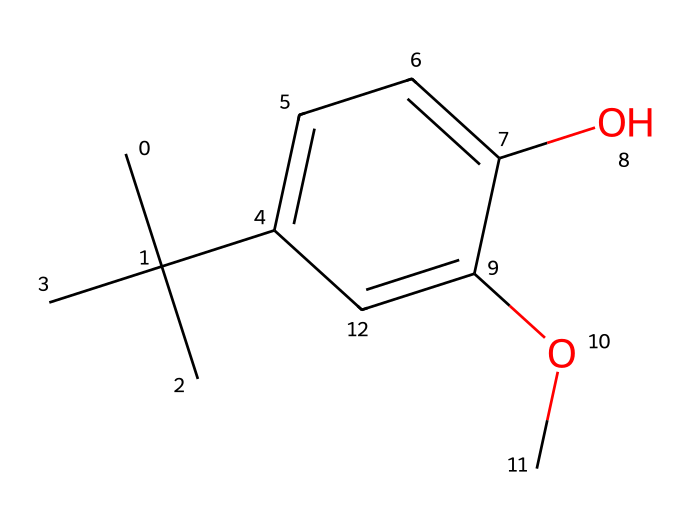What is the molecular formula of butylated hydroxyanisole (BHA)? To determine the molecular formula, count the number of each type of atom in the structure represented by the SMILES. The structure contains 12 carbon (C) atoms, 16 hydrogen (H) atoms, and 3 oxygen (O) atoms. Thus, the molecular formula is C12H16O3.
Answer: C12H16O3 How many oxygen atoms are present in BHA? By analyzing the SMILES representation, we identify the two "O" characters, which represent the oxygen atoms in the chemical structure.
Answer: 3 What type of chemical compound is BHA considered? BHA is classified as a phenolic antioxidant. This is shown by the presence of the benzene-like ring and the hydroxyl (-OH) group on the structure, which are typical characteristics of phenolic compounds.
Answer: phenolic antioxidant Does BHA contain any aromatic rings? The chemical structure includes a `c` (aromatic carbon) in the SMILES, indicating that there is an aromatic ring present in the structure, which is a key feature of phenolic compounds.
Answer: Yes What effect does BHA have on food preservation? BHA acts as an antioxidant, which prevents the oxidation of fats and oils in food, thereby prolonging shelf life and maintaining flavor by inhibiting spoilage.
Answer: Antioxidant How many branched alkyl groups are present in BHA? By examining the chemical structure, we can find that there are three methyl groups connected to a central carbon, forming a tert-butyl group, indicating the presence of one branched alkyl group.
Answer: 1 